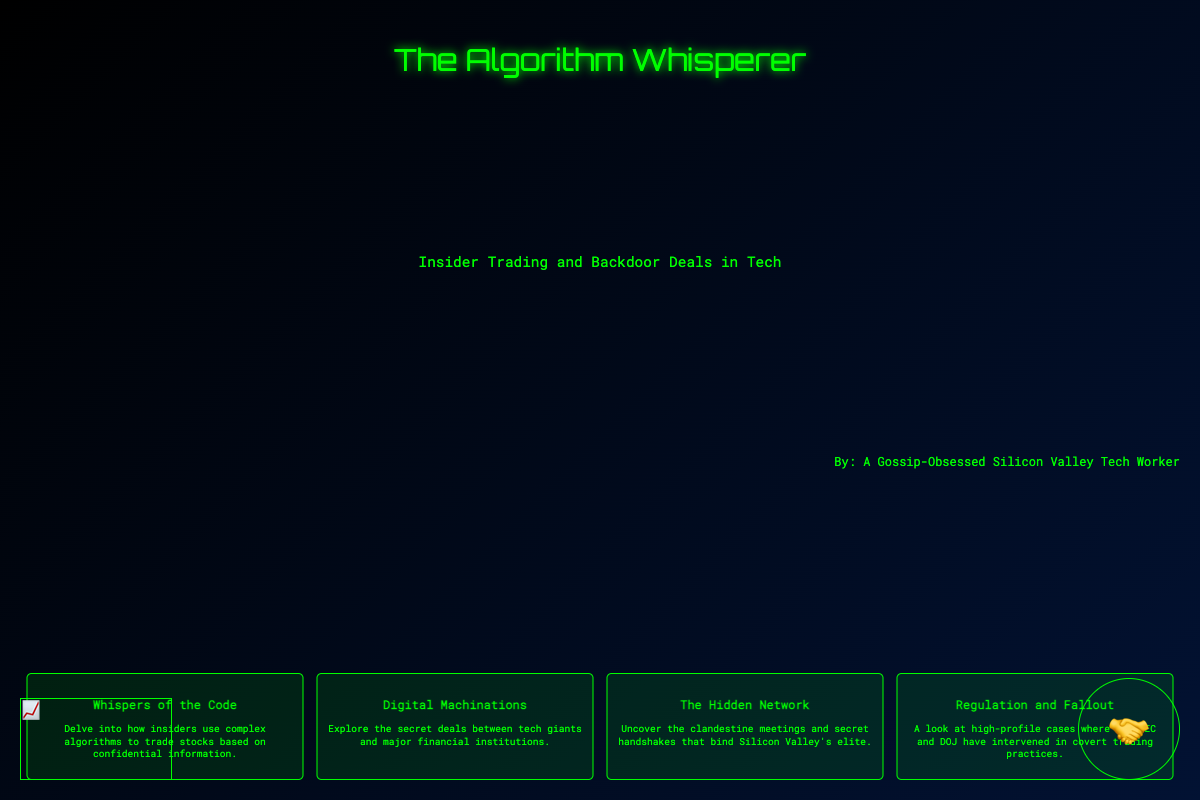What is the title of the book? The title is prominently displayed in the center of the cover.
Answer: The Algorithm Whisperer Who is the author? The author's name is located at the bottom right of the cover.
Answer: A Gossip-Obsessed Silicon Valley Tech Worker What does the subtitle mention? The subtitle is directly below the title and elaborates on the book's theme.
Answer: Insider Trading and Backdoor Deals in Tech How many snippets are featured on the cover? The cover contains a set of four snippets, each highlighting different aspects.
Answer: Four What is the theme of "Whispers of the Code"? The snippet provides insight into a specific topic covered in the book.
Answer: Complex algorithms to trade stocks What visual element represents stock trading? There is an image that illustrates stock trading visually on the cover.
Answer: Stock graph What type of handshake is depicted? The artwork includes a significant visual symbol associated with secret deals.
Answer: Suspicious handshake Which regulatory bodies are mentioned in the last snippet? The mention of specific regulatory bodies is highlighted in the snippet titled "Regulation and Fallout."
Answer: SEC and DOJ 